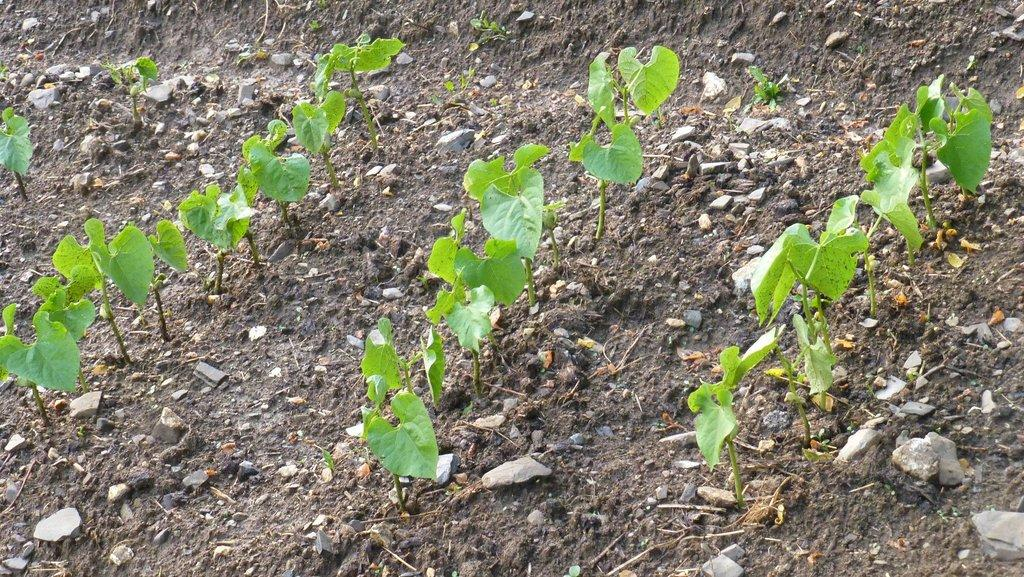What objects are on the ground in the image? There are planets on the ground in the image. What other objects can be seen in the image? There are stones in the image. What type of ice can be seen melting on the woman's memory in the image? There is no woman or memory present in the image, and therefore no ice can be seen melting on it. 